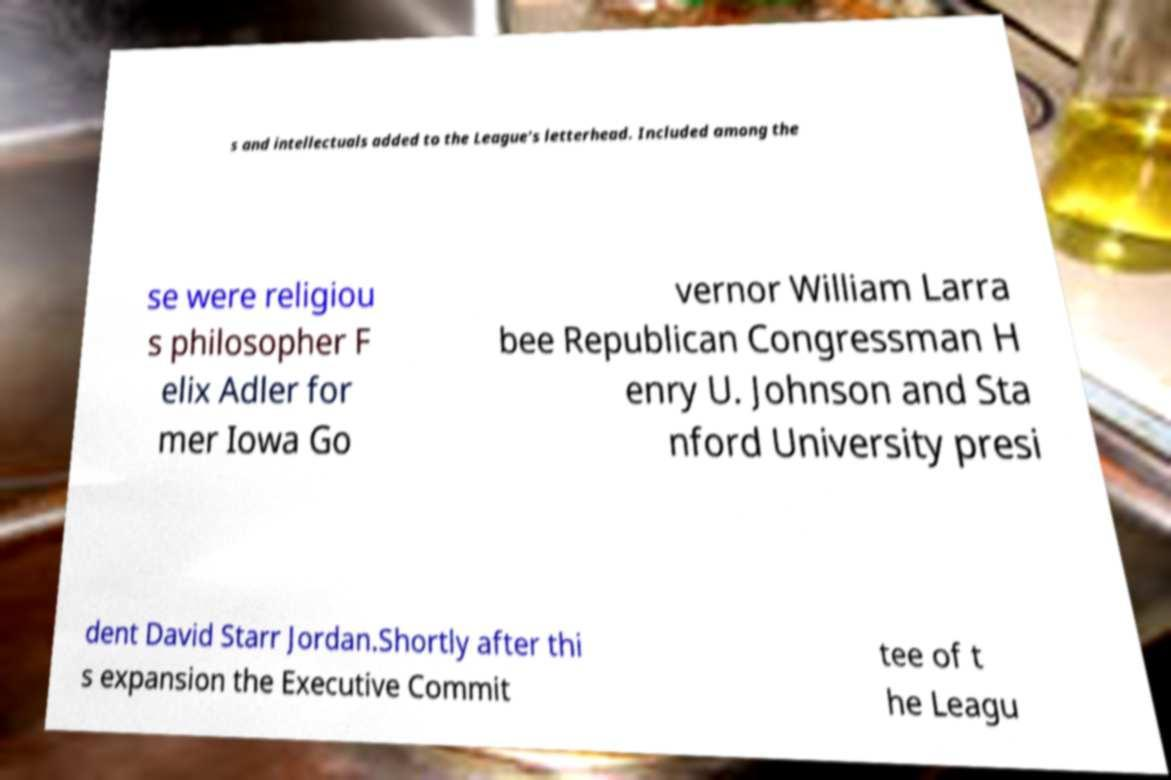Can you read and provide the text displayed in the image?This photo seems to have some interesting text. Can you extract and type it out for me? s and intellectuals added to the League's letterhead. Included among the se were religiou s philosopher F elix Adler for mer Iowa Go vernor William Larra bee Republican Congressman H enry U. Johnson and Sta nford University presi dent David Starr Jordan.Shortly after thi s expansion the Executive Commit tee of t he Leagu 